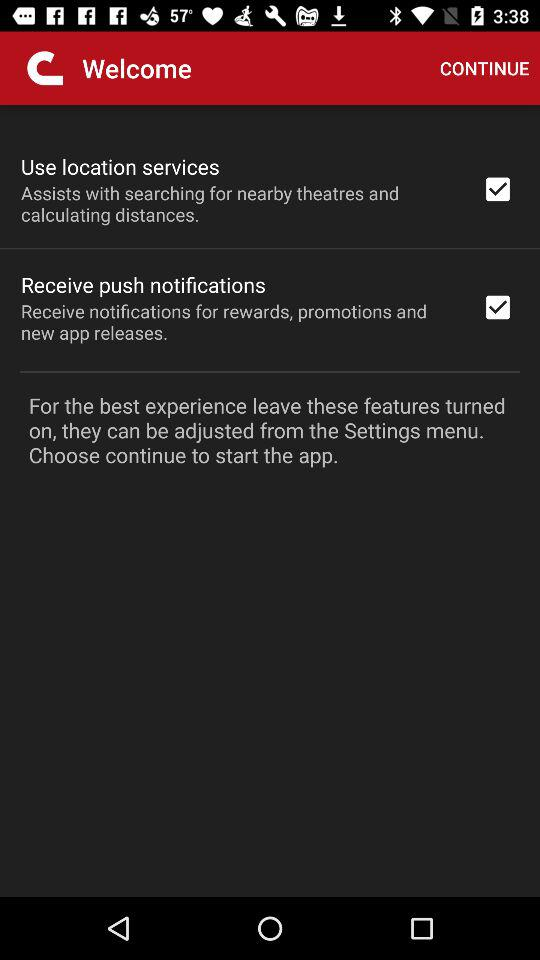What is the status of "Receive push notifications"? The status is "on". 